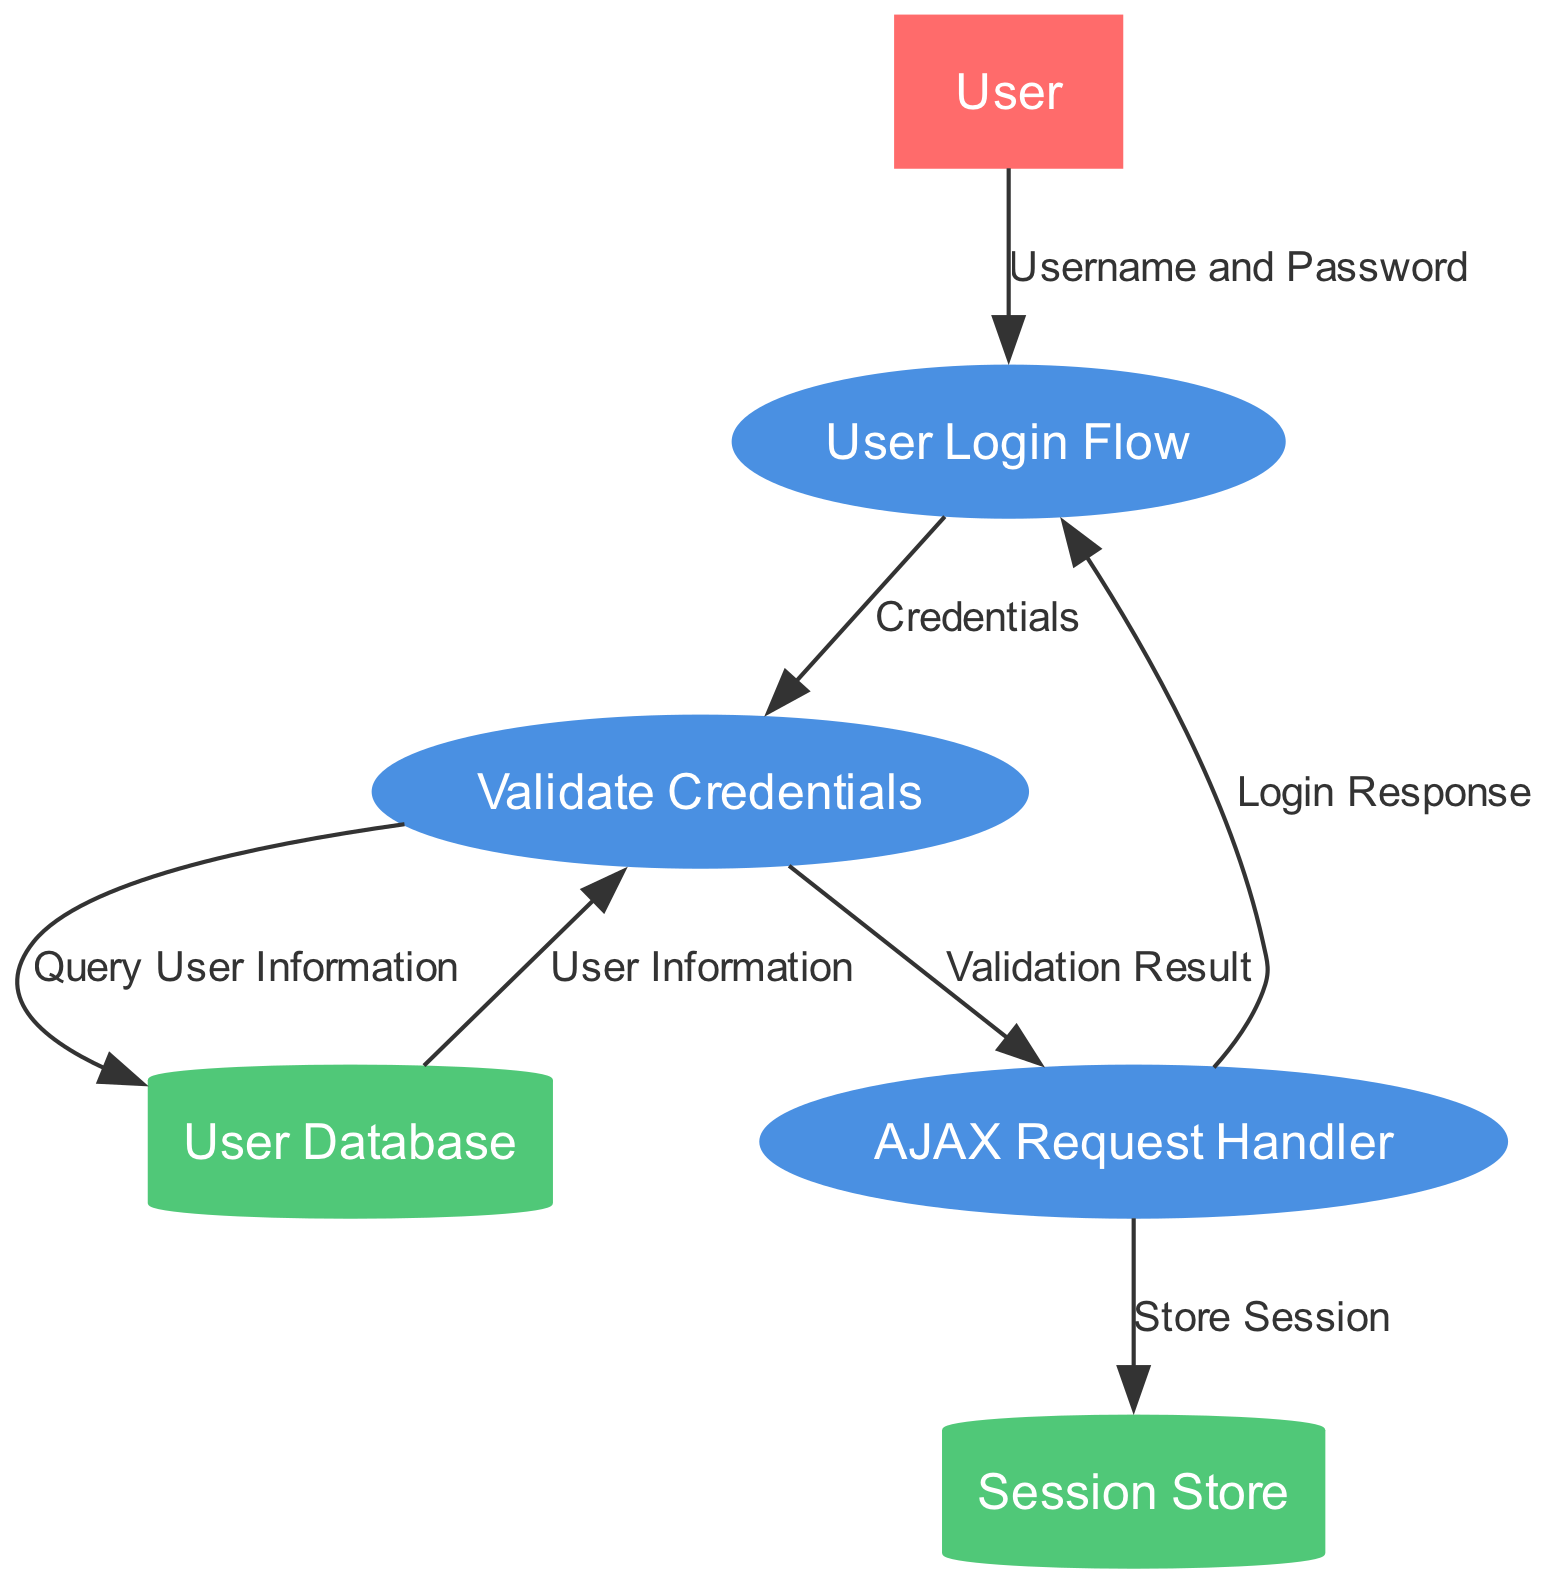What is the primary process in the diagram? The diagram labels the main process as "User Login Flow," which is identified in the processes section.
Answer: User Login Flow How many data stores are present in the diagram? The diagram lists two data stores: "User Database" and "Session Store," which can be counted directly from the data stores section.
Answer: 2 What data is sent from the User to the User Login Flow? According to the data entries, the User provides "Username and Password" to the User Login Flow as their input.
Answer: Username and Password What is the result of the "Validate Credentials" process sent to the AJAX Request Handler? The data flow indicates that the "Validation Result" is sent from "Validate Credentials" to the "AJAX Request Handler."
Answer: Validation Result How many edges connect the data flows in the diagram? By examining the data flows listed, there are six edges connecting different processes and data stores within the diagram.
Answer: 6 What actions occur after the AJAX Request Handler receives the Validation Result? The AJAX Request Handler subsequently sends a "Login Response" to the User Login Flow and also stores a session in the Session Store, indicating two actions that follow the receipt of the Validation Result.
Answer: Login Response, Store Session Which process interacts directly with the User Database? The "Validate Credentials" process interacts with the "User Database" to query user information, as shown by the data flows linked to this data store.
Answer: Validate Credentials Which entity initiates the login process? The diagram shows that the "User" is the external entity that initiates the login process by providing their credentials to the "User Login Flow."
Answer: User What is stored in the Session Store? According to the data flows, the session information for logged-in users, specified as "Store Session," is sent to the Session Store for storage.
Answer: Store Session 